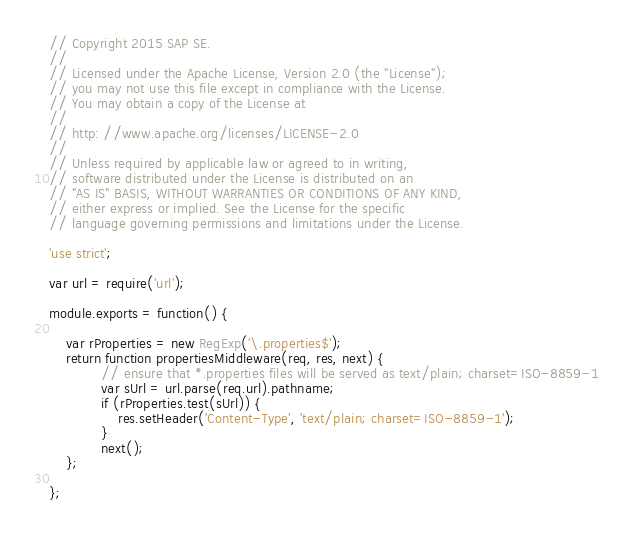Convert code to text. <code><loc_0><loc_0><loc_500><loc_500><_JavaScript_>// Copyright 2015 SAP SE.
//
// Licensed under the Apache License, Version 2.0 (the "License");
// you may not use this file except in compliance with the License.
// You may obtain a copy of the License at
//
// http: //www.apache.org/licenses/LICENSE-2.0
//
// Unless required by applicable law or agreed to in writing,
// software distributed under the License is distributed on an
// "AS IS" BASIS, WITHOUT WARRANTIES OR CONDITIONS OF ANY KIND,
// either express or implied. See the License for the specific
// language governing permissions and limitations under the License.

'use strict';

var url = require('url');

module.exports = function() {

	var rProperties = new RegExp('\.properties$');
	return function propertiesMiddleware(req, res, next) {
			// ensure that *.properties files will be served as text/plain; charset=ISO-8859-1
			var sUrl = url.parse(req.url).pathname;
			if (rProperties.test(sUrl)) {
				res.setHeader('Content-Type', 'text/plain; charset=ISO-8859-1');
			}
			next();
	};

};
</code> 